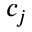<formula> <loc_0><loc_0><loc_500><loc_500>c _ { j }</formula> 